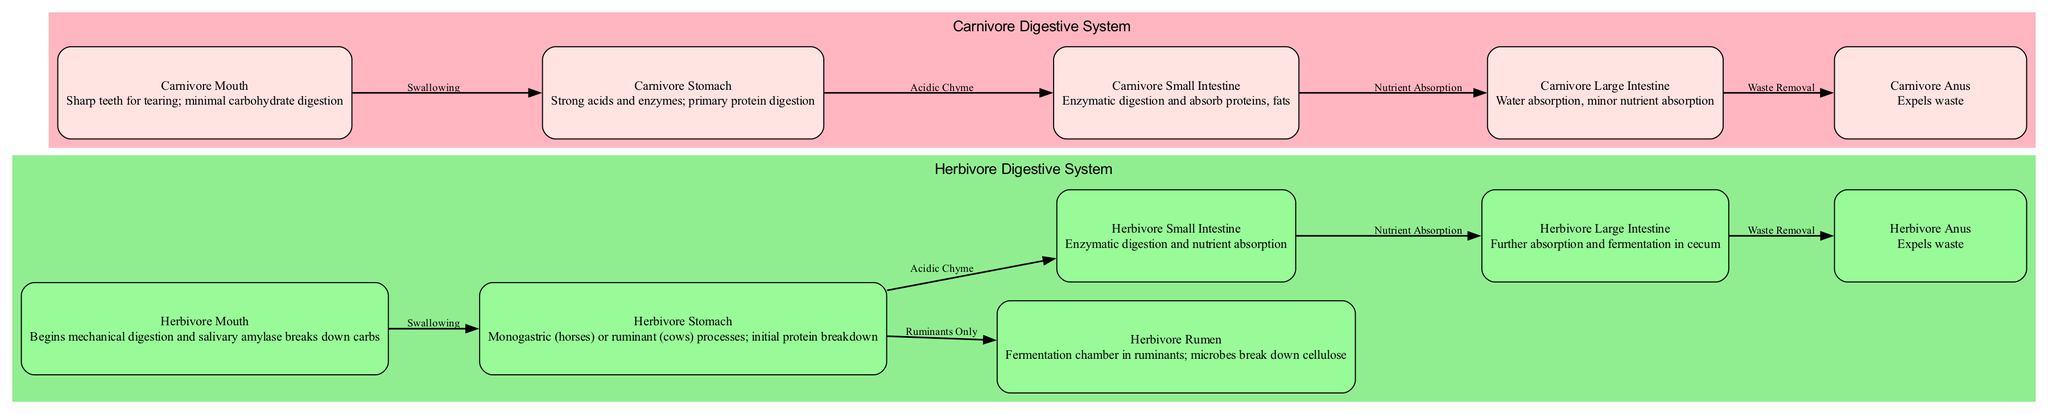What is the first part of the herbivore digestive system? The diagram indicates that the "Herbivore Mouth" is the entry point for food, initiating mechanical digestion and the breakdown of carbohydrates by salivary amylase.
Answer: Herbivore Mouth What type of digestive system do cows have? The diagram specifies that cows possess a ruminant digestive system, which is indicated in the "Herbivore Stomach" as it notes the capability to process protein and includes a connection to the "Rumen".
Answer: Ruminant What is the main function of the carnivore stomach? According to the diagram, the "Carnivore Stomach" is described as having strong acids and enzymes primarily for digesting proteins.
Answer: Protein digestion How many edges are indicated in the herbivore section of the diagram? By counting the connections, there are five edges in the herbivore section that outline the flow from the mouth through to the anus for waste removal.
Answer: Five What is the fermentation chamber in ruminants called? The diagram labels the "Rumen" specifically as the fermentation chamber where cellulose is broken down by microbes.
Answer: Rumen What is the primary nutrient absorbed in the carnivore small intestine? The "Carnivore Small Intestine" section of the diagram refers to the absorption of proteins and fats, indicating the key nutrients of focus in this part of the digestion process.
Answer: Proteins, fats How does the herbivore large intestine contribute to digestion? The "Herbivore Large Intestine" description states that it plays a role in further absorption and fermentation in the cecum, which is essential for extracting residual nutrients.
Answer: Further absorption and fermentation What is the final step of the carnivore digestive process? The diagram reveals that the last step for the carnivore digestive system is the expulsion of waste through the "Carnivore Anus".
Answer: Expels waste 